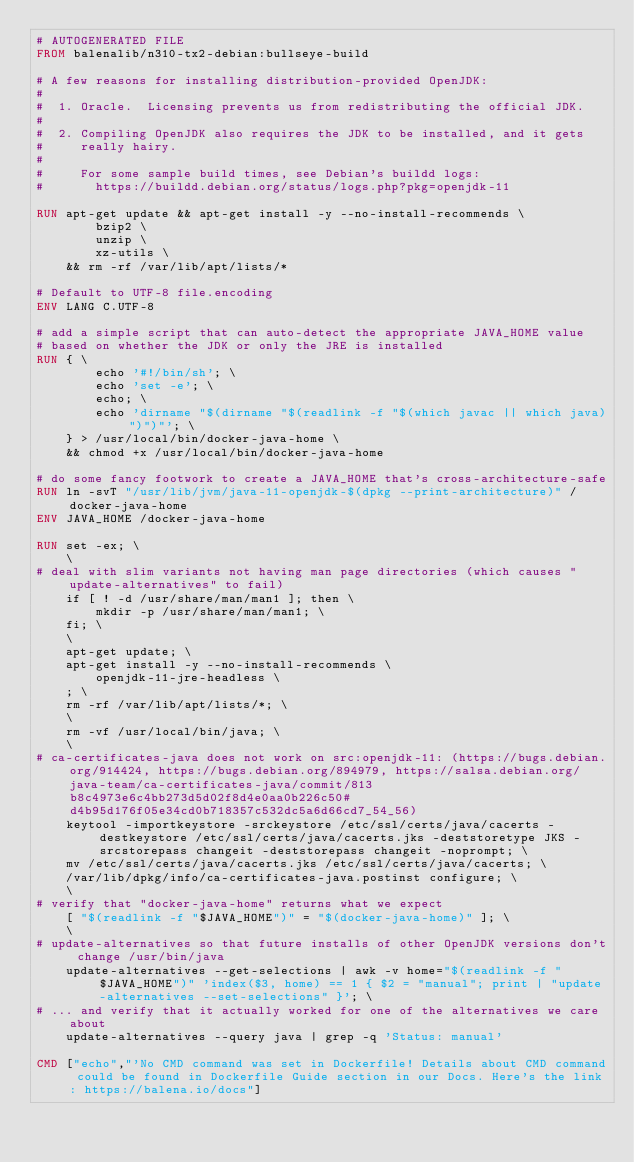Convert code to text. <code><loc_0><loc_0><loc_500><loc_500><_Dockerfile_># AUTOGENERATED FILE
FROM balenalib/n310-tx2-debian:bullseye-build

# A few reasons for installing distribution-provided OpenJDK:
#
#  1. Oracle.  Licensing prevents us from redistributing the official JDK.
#
#  2. Compiling OpenJDK also requires the JDK to be installed, and it gets
#     really hairy.
#
#     For some sample build times, see Debian's buildd logs:
#       https://buildd.debian.org/status/logs.php?pkg=openjdk-11

RUN apt-get update && apt-get install -y --no-install-recommends \
		bzip2 \
		unzip \
		xz-utils \
	&& rm -rf /var/lib/apt/lists/*

# Default to UTF-8 file.encoding
ENV LANG C.UTF-8

# add a simple script that can auto-detect the appropriate JAVA_HOME value
# based on whether the JDK or only the JRE is installed
RUN { \
		echo '#!/bin/sh'; \
		echo 'set -e'; \
		echo; \
		echo 'dirname "$(dirname "$(readlink -f "$(which javac || which java)")")"'; \
	} > /usr/local/bin/docker-java-home \
	&& chmod +x /usr/local/bin/docker-java-home

# do some fancy footwork to create a JAVA_HOME that's cross-architecture-safe
RUN ln -svT "/usr/lib/jvm/java-11-openjdk-$(dpkg --print-architecture)" /docker-java-home
ENV JAVA_HOME /docker-java-home

RUN set -ex; \
	\
# deal with slim variants not having man page directories (which causes "update-alternatives" to fail)
	if [ ! -d /usr/share/man/man1 ]; then \
		mkdir -p /usr/share/man/man1; \
	fi; \
	\
	apt-get update; \
	apt-get install -y --no-install-recommends \
		openjdk-11-jre-headless \
	; \
	rm -rf /var/lib/apt/lists/*; \
	\
	rm -vf /usr/local/bin/java; \
	\
# ca-certificates-java does not work on src:openjdk-11: (https://bugs.debian.org/914424, https://bugs.debian.org/894979, https://salsa.debian.org/java-team/ca-certificates-java/commit/813b8c4973e6c4bb273d5d02f8d4e0aa0b226c50#d4b95d176f05e34cd0b718357c532dc5a6d66cd7_54_56)
	keytool -importkeystore -srckeystore /etc/ssl/certs/java/cacerts -destkeystore /etc/ssl/certs/java/cacerts.jks -deststoretype JKS -srcstorepass changeit -deststorepass changeit -noprompt; \
	mv /etc/ssl/certs/java/cacerts.jks /etc/ssl/certs/java/cacerts; \
	/var/lib/dpkg/info/ca-certificates-java.postinst configure; \
	\
# verify that "docker-java-home" returns what we expect
	[ "$(readlink -f "$JAVA_HOME")" = "$(docker-java-home)" ]; \
	\
# update-alternatives so that future installs of other OpenJDK versions don't change /usr/bin/java
	update-alternatives --get-selections | awk -v home="$(readlink -f "$JAVA_HOME")" 'index($3, home) == 1 { $2 = "manual"; print | "update-alternatives --set-selections" }'; \
# ... and verify that it actually worked for one of the alternatives we care about
	update-alternatives --query java | grep -q 'Status: manual'

CMD ["echo","'No CMD command was set in Dockerfile! Details about CMD command could be found in Dockerfile Guide section in our Docs. Here's the link: https://balena.io/docs"]
</code> 